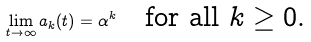Convert formula to latex. <formula><loc_0><loc_0><loc_500><loc_500>\lim _ { t \to \infty } a _ { k } ( t ) = \alpha ^ { k } \quad \text {for all $k\geq0$.}</formula> 